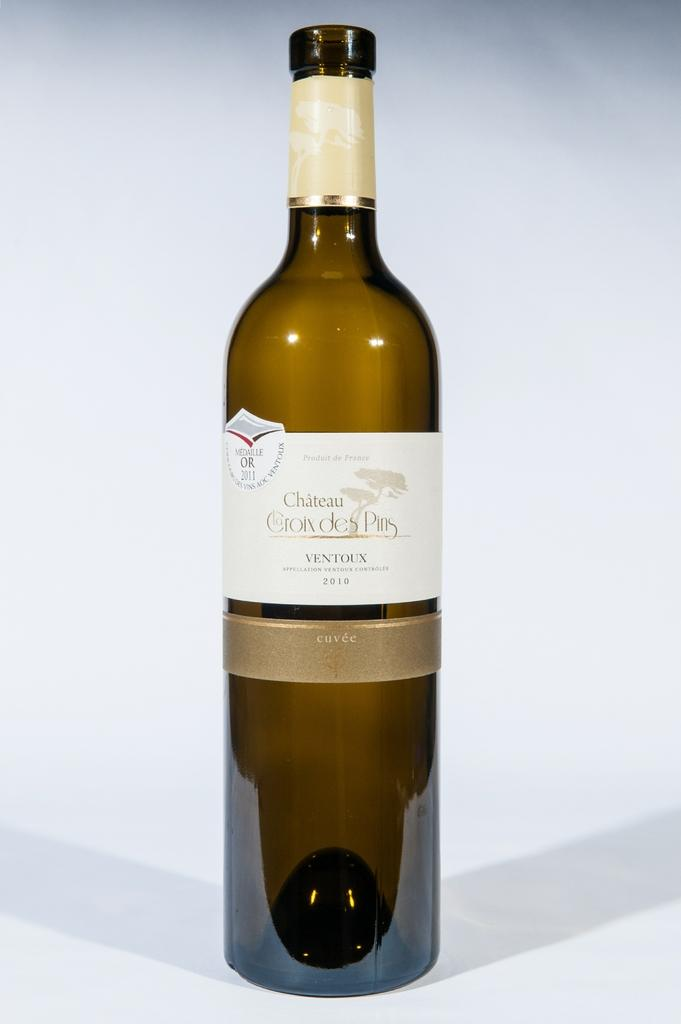<image>
Present a compact description of the photo's key features. Wine bottle called Chateau Croix des Pins in front of a white background. 